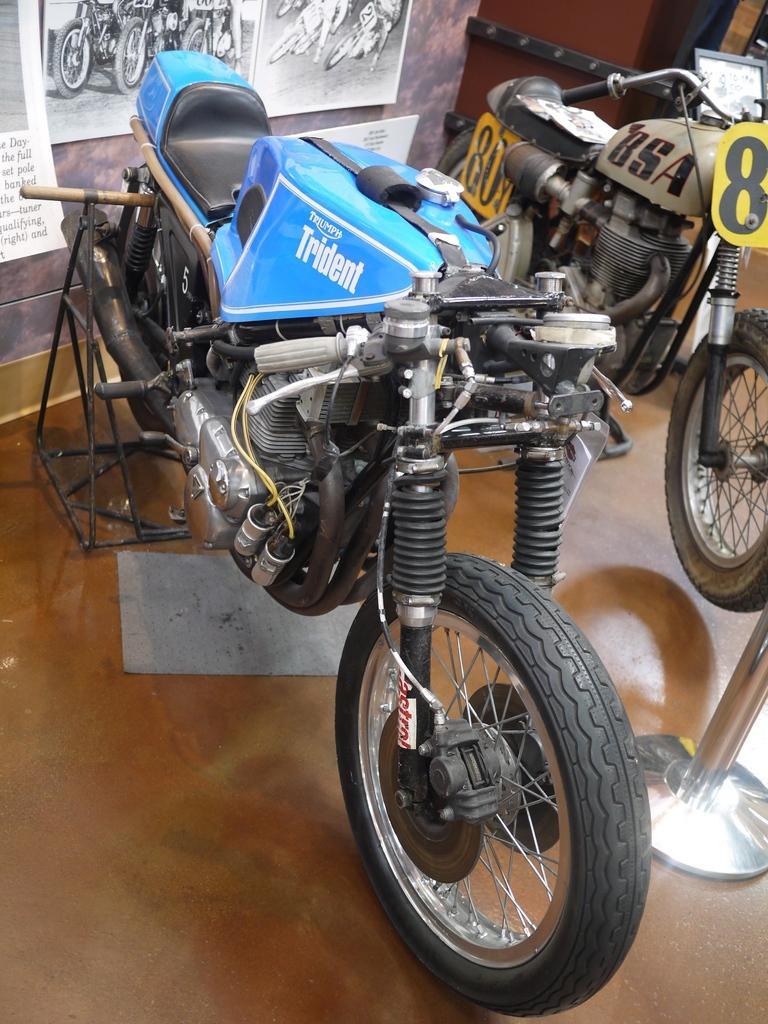In one or two sentences, can you explain what this image depicts? We can see bikes and stand on the floor,behind these bikes we can see posts on a wall. 